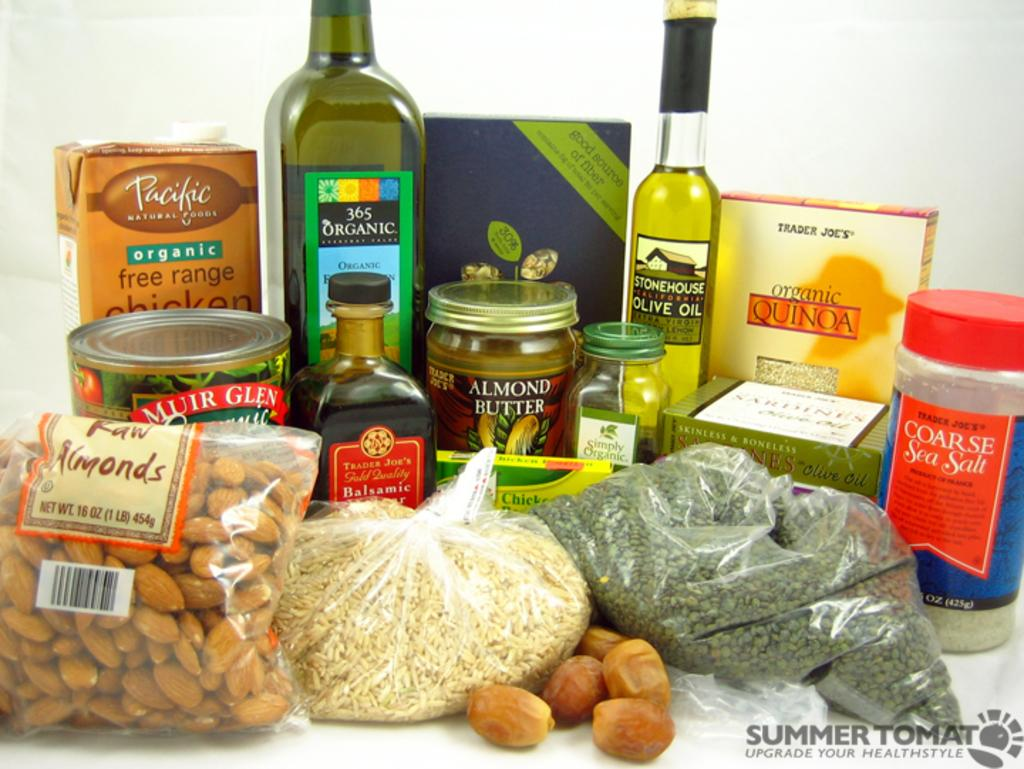<image>
Provide a brief description of the given image. A variety of bottles, can and packaged food which one bag is Almonds. 